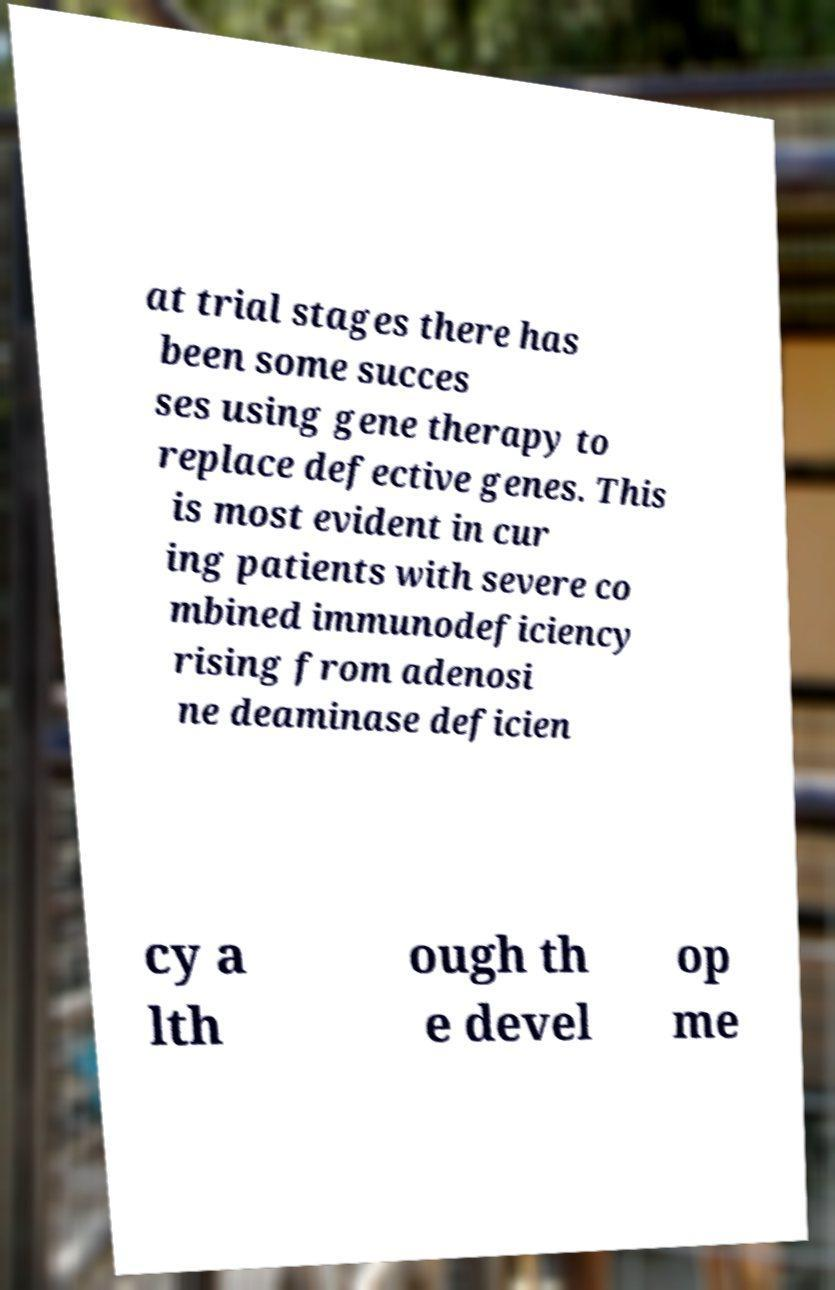Please read and relay the text visible in this image. What does it say? at trial stages there has been some succes ses using gene therapy to replace defective genes. This is most evident in cur ing patients with severe co mbined immunodeficiency rising from adenosi ne deaminase deficien cy a lth ough th e devel op me 